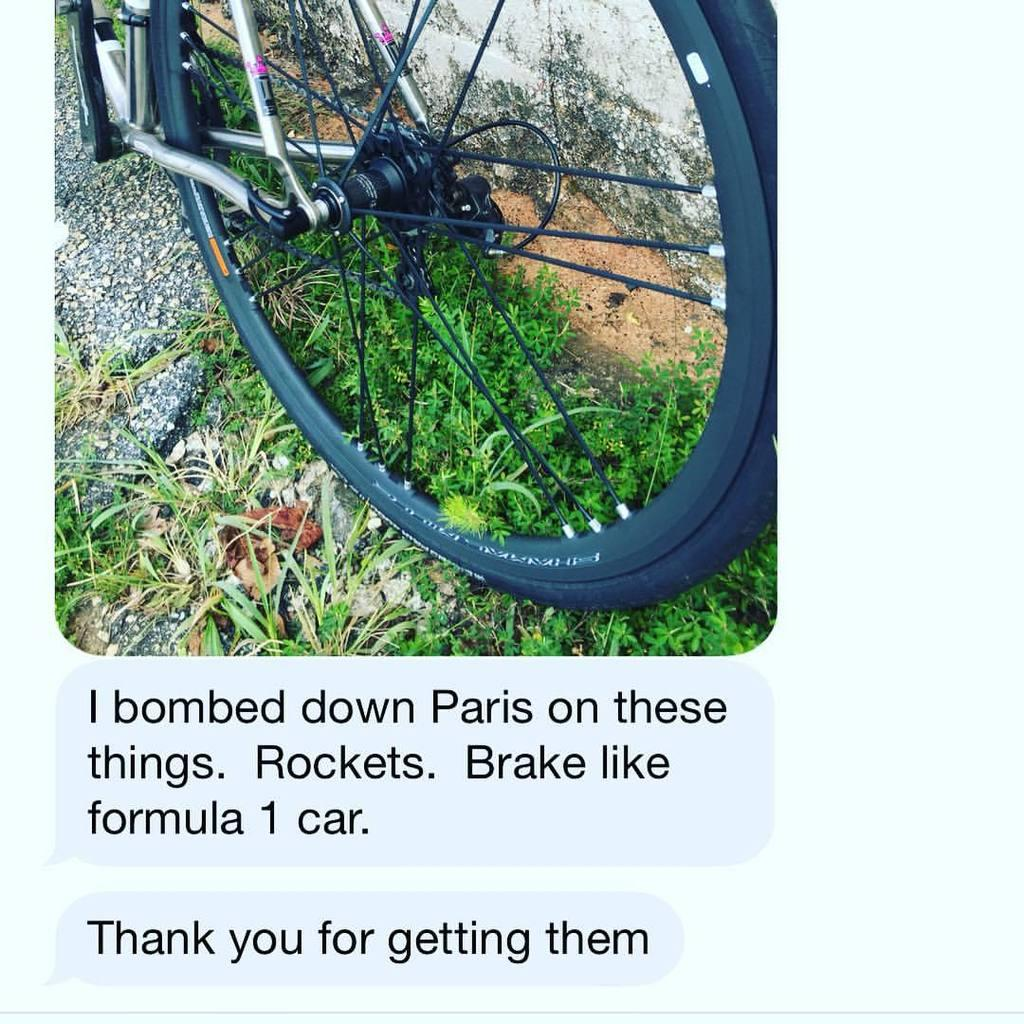What is the main object in the image? There is a wheel in the image. What can be seen near the wall in the image? There are plants beside the wall in the image. Is there any text present in the image? Yes, there is a text at the bottom of the image. How many mice are hiding in the wheel in the image? There are no mice present in the image; it only features a wheel, plants, and text. 